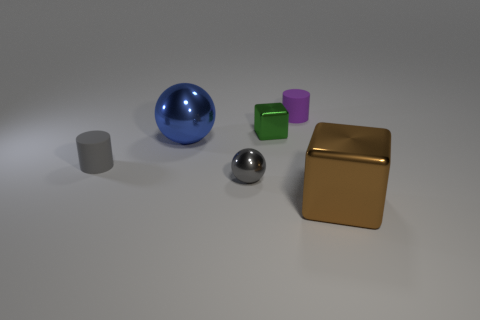Add 3 purple objects. How many objects exist? 9 Subtract all cylinders. How many objects are left? 4 Subtract all metal things. Subtract all tiny brown blocks. How many objects are left? 2 Add 4 big spheres. How many big spheres are left? 5 Add 1 small gray shiny balls. How many small gray shiny balls exist? 2 Subtract 0 purple spheres. How many objects are left? 6 